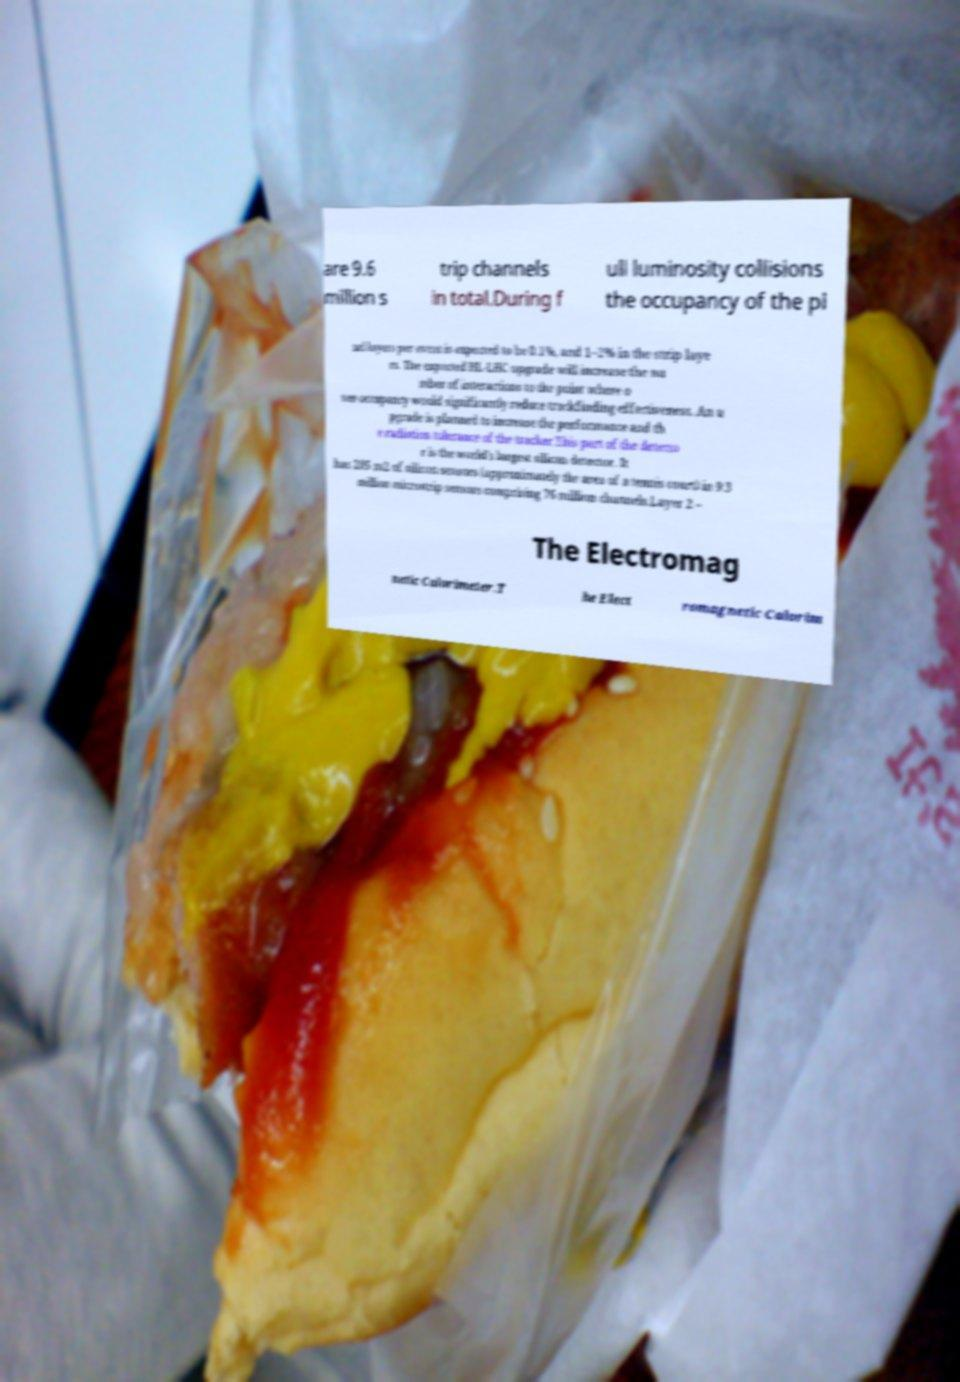Can you read and provide the text displayed in the image?This photo seems to have some interesting text. Can you extract and type it out for me? are 9.6 million s trip channels in total.During f ull luminosity collisions the occupancy of the pi xel layers per event is expected to be 0.1%, and 1–2% in the strip laye rs. The expected HL-LHC upgrade will increase the nu mber of interactions to the point where o ver-occupancy would significantly reduce trackfinding effectiveness. An u pgrade is planned to increase the performance and th e radiation tolerance of the tracker.This part of the detecto r is the world's largest silicon detector. It has 205 m2 of silicon sensors (approximately the area of a tennis court) in 9.3 million microstrip sensors comprising 76 million channels.Layer 2 – The Electromag netic Calorimeter.T he Elect romagnetic Calorim 